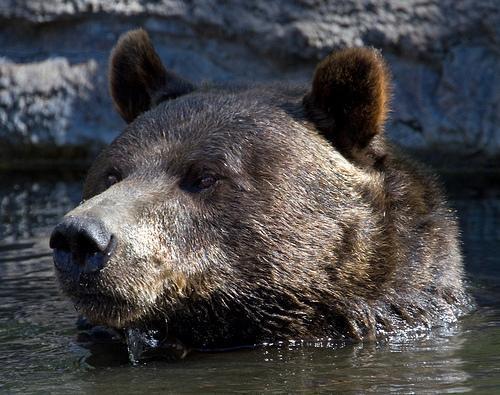How many bears?
Give a very brief answer. 1. 